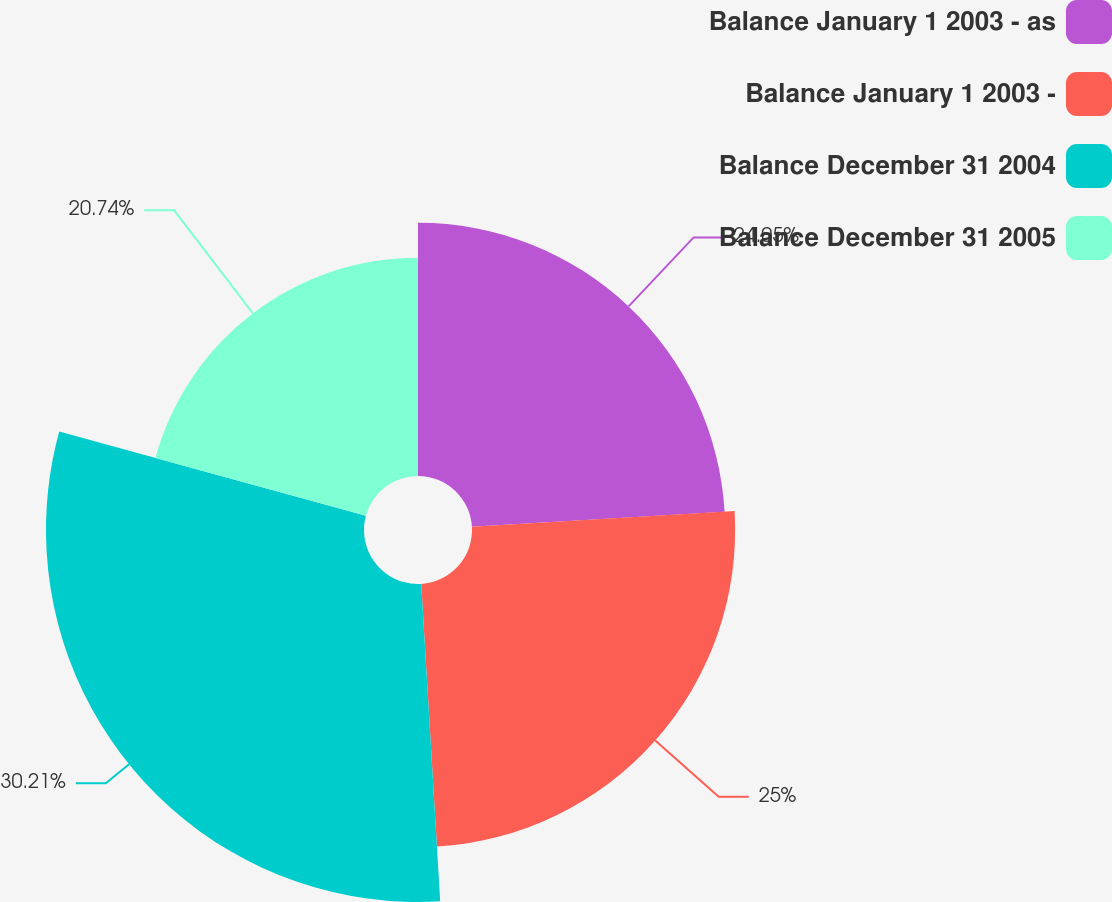Convert chart. <chart><loc_0><loc_0><loc_500><loc_500><pie_chart><fcel>Balance January 1 2003 - as<fcel>Balance January 1 2003 -<fcel>Balance December 31 2004<fcel>Balance December 31 2005<nl><fcel>24.05%<fcel>25.0%<fcel>30.21%<fcel>20.74%<nl></chart> 